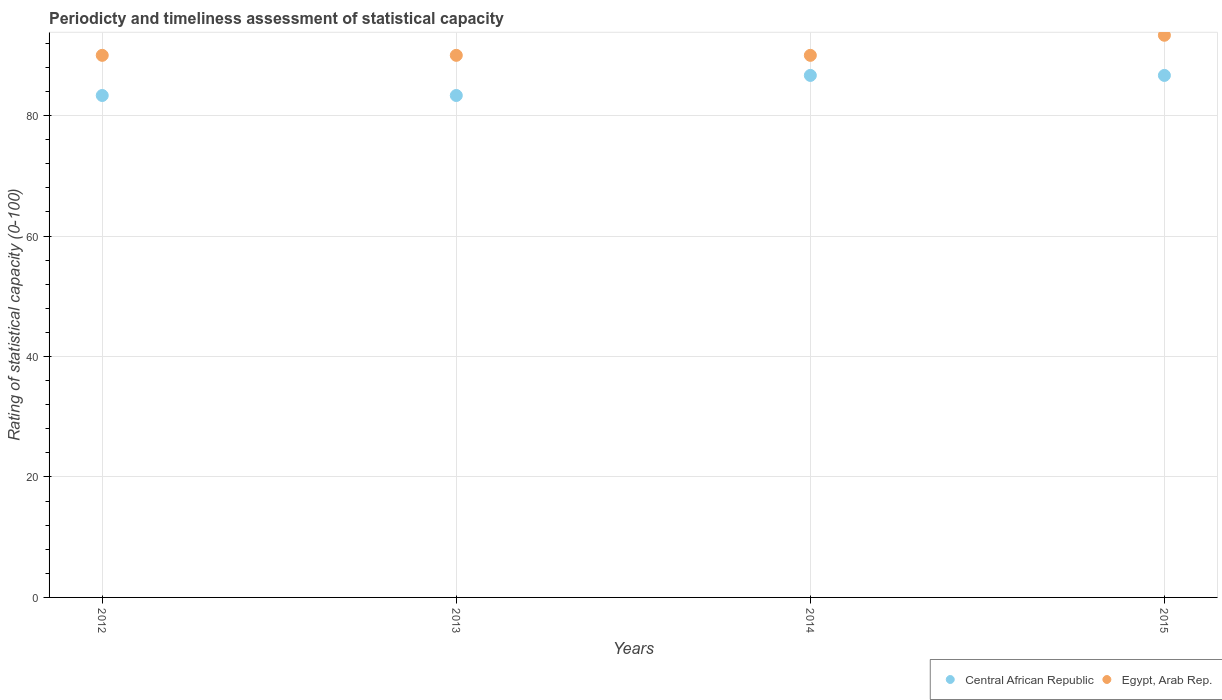How many different coloured dotlines are there?
Provide a short and direct response. 2. Is the number of dotlines equal to the number of legend labels?
Offer a terse response. Yes. What is the rating of statistical capacity in Egypt, Arab Rep. in 2012?
Keep it short and to the point. 90. Across all years, what is the maximum rating of statistical capacity in Egypt, Arab Rep.?
Make the answer very short. 93.33. In which year was the rating of statistical capacity in Central African Republic maximum?
Offer a terse response. 2015. In which year was the rating of statistical capacity in Egypt, Arab Rep. minimum?
Your response must be concise. 2012. What is the total rating of statistical capacity in Central African Republic in the graph?
Give a very brief answer. 340. What is the difference between the rating of statistical capacity in Egypt, Arab Rep. in 2013 and that in 2015?
Make the answer very short. -3.33. What is the difference between the rating of statistical capacity in Central African Republic in 2015 and the rating of statistical capacity in Egypt, Arab Rep. in 2014?
Ensure brevity in your answer.  -3.33. What is the average rating of statistical capacity in Egypt, Arab Rep. per year?
Offer a very short reply. 90.83. In the year 2014, what is the difference between the rating of statistical capacity in Egypt, Arab Rep. and rating of statistical capacity in Central African Republic?
Keep it short and to the point. 3.33. In how many years, is the rating of statistical capacity in Egypt, Arab Rep. greater than 40?
Keep it short and to the point. 4. What is the ratio of the rating of statistical capacity in Central African Republic in 2012 to that in 2014?
Your answer should be very brief. 0.96. What is the difference between the highest and the second highest rating of statistical capacity in Central African Republic?
Offer a very short reply. 0. What is the difference between the highest and the lowest rating of statistical capacity in Egypt, Arab Rep.?
Your answer should be very brief. 3.33. In how many years, is the rating of statistical capacity in Central African Republic greater than the average rating of statistical capacity in Central African Republic taken over all years?
Make the answer very short. 2. Is the rating of statistical capacity in Central African Republic strictly greater than the rating of statistical capacity in Egypt, Arab Rep. over the years?
Your response must be concise. No. How many dotlines are there?
Ensure brevity in your answer.  2. What is the difference between two consecutive major ticks on the Y-axis?
Ensure brevity in your answer.  20. Where does the legend appear in the graph?
Provide a short and direct response. Bottom right. How many legend labels are there?
Offer a terse response. 2. What is the title of the graph?
Make the answer very short. Periodicty and timeliness assessment of statistical capacity. What is the label or title of the Y-axis?
Provide a short and direct response. Rating of statistical capacity (0-100). What is the Rating of statistical capacity (0-100) in Central African Republic in 2012?
Keep it short and to the point. 83.33. What is the Rating of statistical capacity (0-100) of Egypt, Arab Rep. in 2012?
Your answer should be compact. 90. What is the Rating of statistical capacity (0-100) of Central African Republic in 2013?
Keep it short and to the point. 83.33. What is the Rating of statistical capacity (0-100) in Egypt, Arab Rep. in 2013?
Your answer should be very brief. 90. What is the Rating of statistical capacity (0-100) in Central African Republic in 2014?
Keep it short and to the point. 86.67. What is the Rating of statistical capacity (0-100) of Central African Republic in 2015?
Ensure brevity in your answer.  86.67. What is the Rating of statistical capacity (0-100) in Egypt, Arab Rep. in 2015?
Ensure brevity in your answer.  93.33. Across all years, what is the maximum Rating of statistical capacity (0-100) of Central African Republic?
Your response must be concise. 86.67. Across all years, what is the maximum Rating of statistical capacity (0-100) in Egypt, Arab Rep.?
Provide a succinct answer. 93.33. Across all years, what is the minimum Rating of statistical capacity (0-100) in Central African Republic?
Keep it short and to the point. 83.33. Across all years, what is the minimum Rating of statistical capacity (0-100) of Egypt, Arab Rep.?
Ensure brevity in your answer.  90. What is the total Rating of statistical capacity (0-100) in Central African Republic in the graph?
Give a very brief answer. 340. What is the total Rating of statistical capacity (0-100) in Egypt, Arab Rep. in the graph?
Give a very brief answer. 363.33. What is the difference between the Rating of statistical capacity (0-100) in Egypt, Arab Rep. in 2012 and that in 2013?
Your response must be concise. 0. What is the difference between the Rating of statistical capacity (0-100) of Central African Republic in 2012 and that in 2014?
Your answer should be compact. -3.33. What is the difference between the Rating of statistical capacity (0-100) of Egypt, Arab Rep. in 2012 and that in 2014?
Provide a short and direct response. 0. What is the difference between the Rating of statistical capacity (0-100) of Central African Republic in 2012 and that in 2015?
Provide a succinct answer. -3.33. What is the difference between the Rating of statistical capacity (0-100) of Egypt, Arab Rep. in 2012 and that in 2015?
Offer a very short reply. -3.33. What is the difference between the Rating of statistical capacity (0-100) in Central African Republic in 2013 and that in 2015?
Keep it short and to the point. -3.33. What is the difference between the Rating of statistical capacity (0-100) in Egypt, Arab Rep. in 2013 and that in 2015?
Make the answer very short. -3.33. What is the difference between the Rating of statistical capacity (0-100) of Central African Republic in 2014 and that in 2015?
Provide a short and direct response. -0. What is the difference between the Rating of statistical capacity (0-100) in Egypt, Arab Rep. in 2014 and that in 2015?
Your answer should be compact. -3.33. What is the difference between the Rating of statistical capacity (0-100) of Central African Republic in 2012 and the Rating of statistical capacity (0-100) of Egypt, Arab Rep. in 2013?
Ensure brevity in your answer.  -6.67. What is the difference between the Rating of statistical capacity (0-100) in Central African Republic in 2012 and the Rating of statistical capacity (0-100) in Egypt, Arab Rep. in 2014?
Your answer should be very brief. -6.67. What is the difference between the Rating of statistical capacity (0-100) of Central African Republic in 2012 and the Rating of statistical capacity (0-100) of Egypt, Arab Rep. in 2015?
Your answer should be very brief. -10. What is the difference between the Rating of statistical capacity (0-100) in Central African Republic in 2013 and the Rating of statistical capacity (0-100) in Egypt, Arab Rep. in 2014?
Offer a terse response. -6.67. What is the difference between the Rating of statistical capacity (0-100) in Central African Republic in 2013 and the Rating of statistical capacity (0-100) in Egypt, Arab Rep. in 2015?
Keep it short and to the point. -10. What is the difference between the Rating of statistical capacity (0-100) in Central African Republic in 2014 and the Rating of statistical capacity (0-100) in Egypt, Arab Rep. in 2015?
Offer a terse response. -6.67. What is the average Rating of statistical capacity (0-100) in Egypt, Arab Rep. per year?
Offer a very short reply. 90.83. In the year 2012, what is the difference between the Rating of statistical capacity (0-100) of Central African Republic and Rating of statistical capacity (0-100) of Egypt, Arab Rep.?
Offer a terse response. -6.67. In the year 2013, what is the difference between the Rating of statistical capacity (0-100) of Central African Republic and Rating of statistical capacity (0-100) of Egypt, Arab Rep.?
Provide a short and direct response. -6.67. In the year 2015, what is the difference between the Rating of statistical capacity (0-100) of Central African Republic and Rating of statistical capacity (0-100) of Egypt, Arab Rep.?
Provide a short and direct response. -6.67. What is the ratio of the Rating of statistical capacity (0-100) in Egypt, Arab Rep. in 2012 to that in 2013?
Provide a succinct answer. 1. What is the ratio of the Rating of statistical capacity (0-100) in Central African Republic in 2012 to that in 2014?
Keep it short and to the point. 0.96. What is the ratio of the Rating of statistical capacity (0-100) of Egypt, Arab Rep. in 2012 to that in 2014?
Give a very brief answer. 1. What is the ratio of the Rating of statistical capacity (0-100) of Central African Republic in 2012 to that in 2015?
Give a very brief answer. 0.96. What is the ratio of the Rating of statistical capacity (0-100) of Central African Republic in 2013 to that in 2014?
Your answer should be very brief. 0.96. What is the ratio of the Rating of statistical capacity (0-100) in Central African Republic in 2013 to that in 2015?
Provide a short and direct response. 0.96. What is the ratio of the Rating of statistical capacity (0-100) of Egypt, Arab Rep. in 2014 to that in 2015?
Offer a very short reply. 0.96. What is the difference between the highest and the second highest Rating of statistical capacity (0-100) in Central African Republic?
Your answer should be compact. 0. What is the difference between the highest and the second highest Rating of statistical capacity (0-100) of Egypt, Arab Rep.?
Provide a succinct answer. 3.33. What is the difference between the highest and the lowest Rating of statistical capacity (0-100) of Central African Republic?
Your answer should be very brief. 3.33. What is the difference between the highest and the lowest Rating of statistical capacity (0-100) in Egypt, Arab Rep.?
Provide a short and direct response. 3.33. 